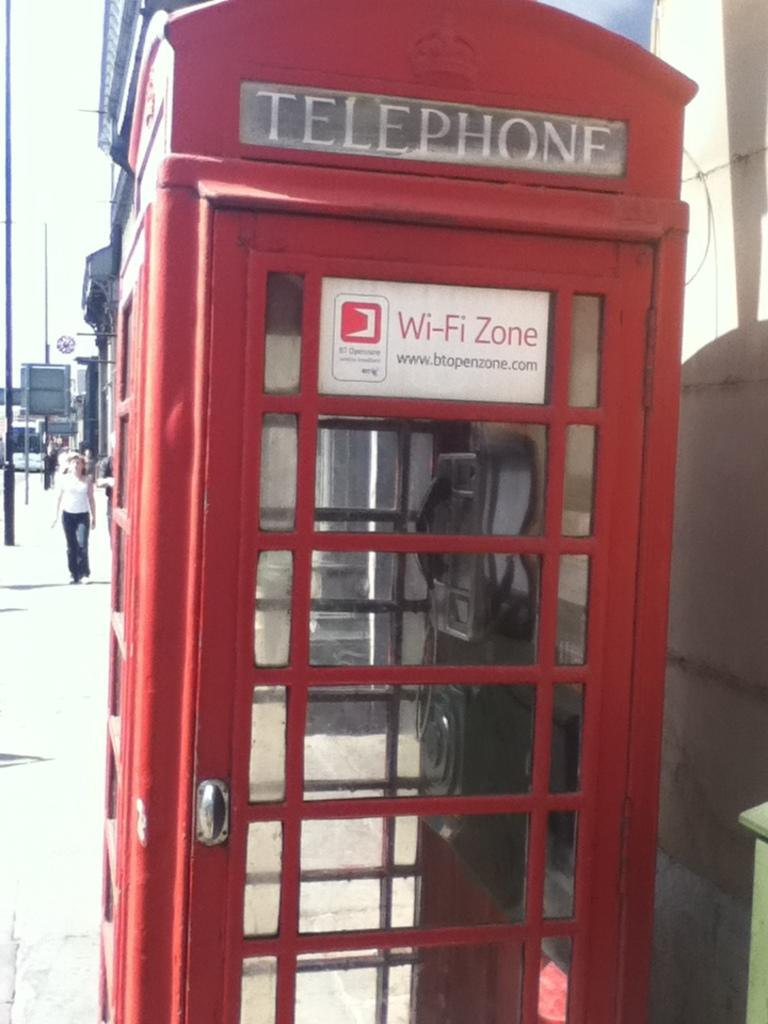Provide a one-sentence caption for the provided image. The red telephone booth is a wireless hotspot. 